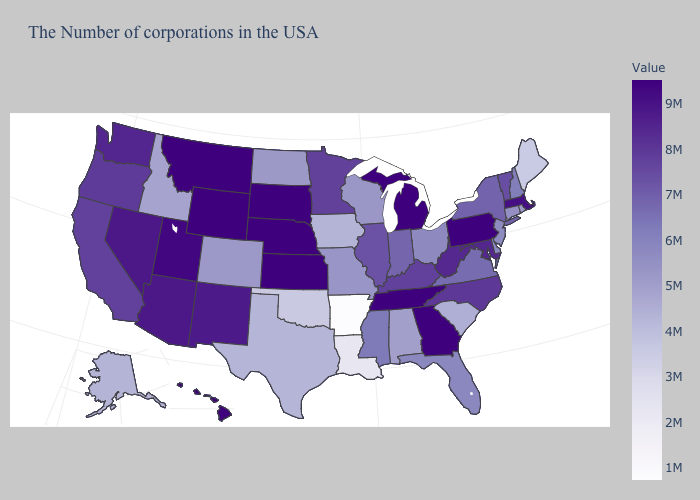Which states have the lowest value in the USA?
Be succinct. Arkansas. Does West Virginia have a higher value than Utah?
Concise answer only. No. 